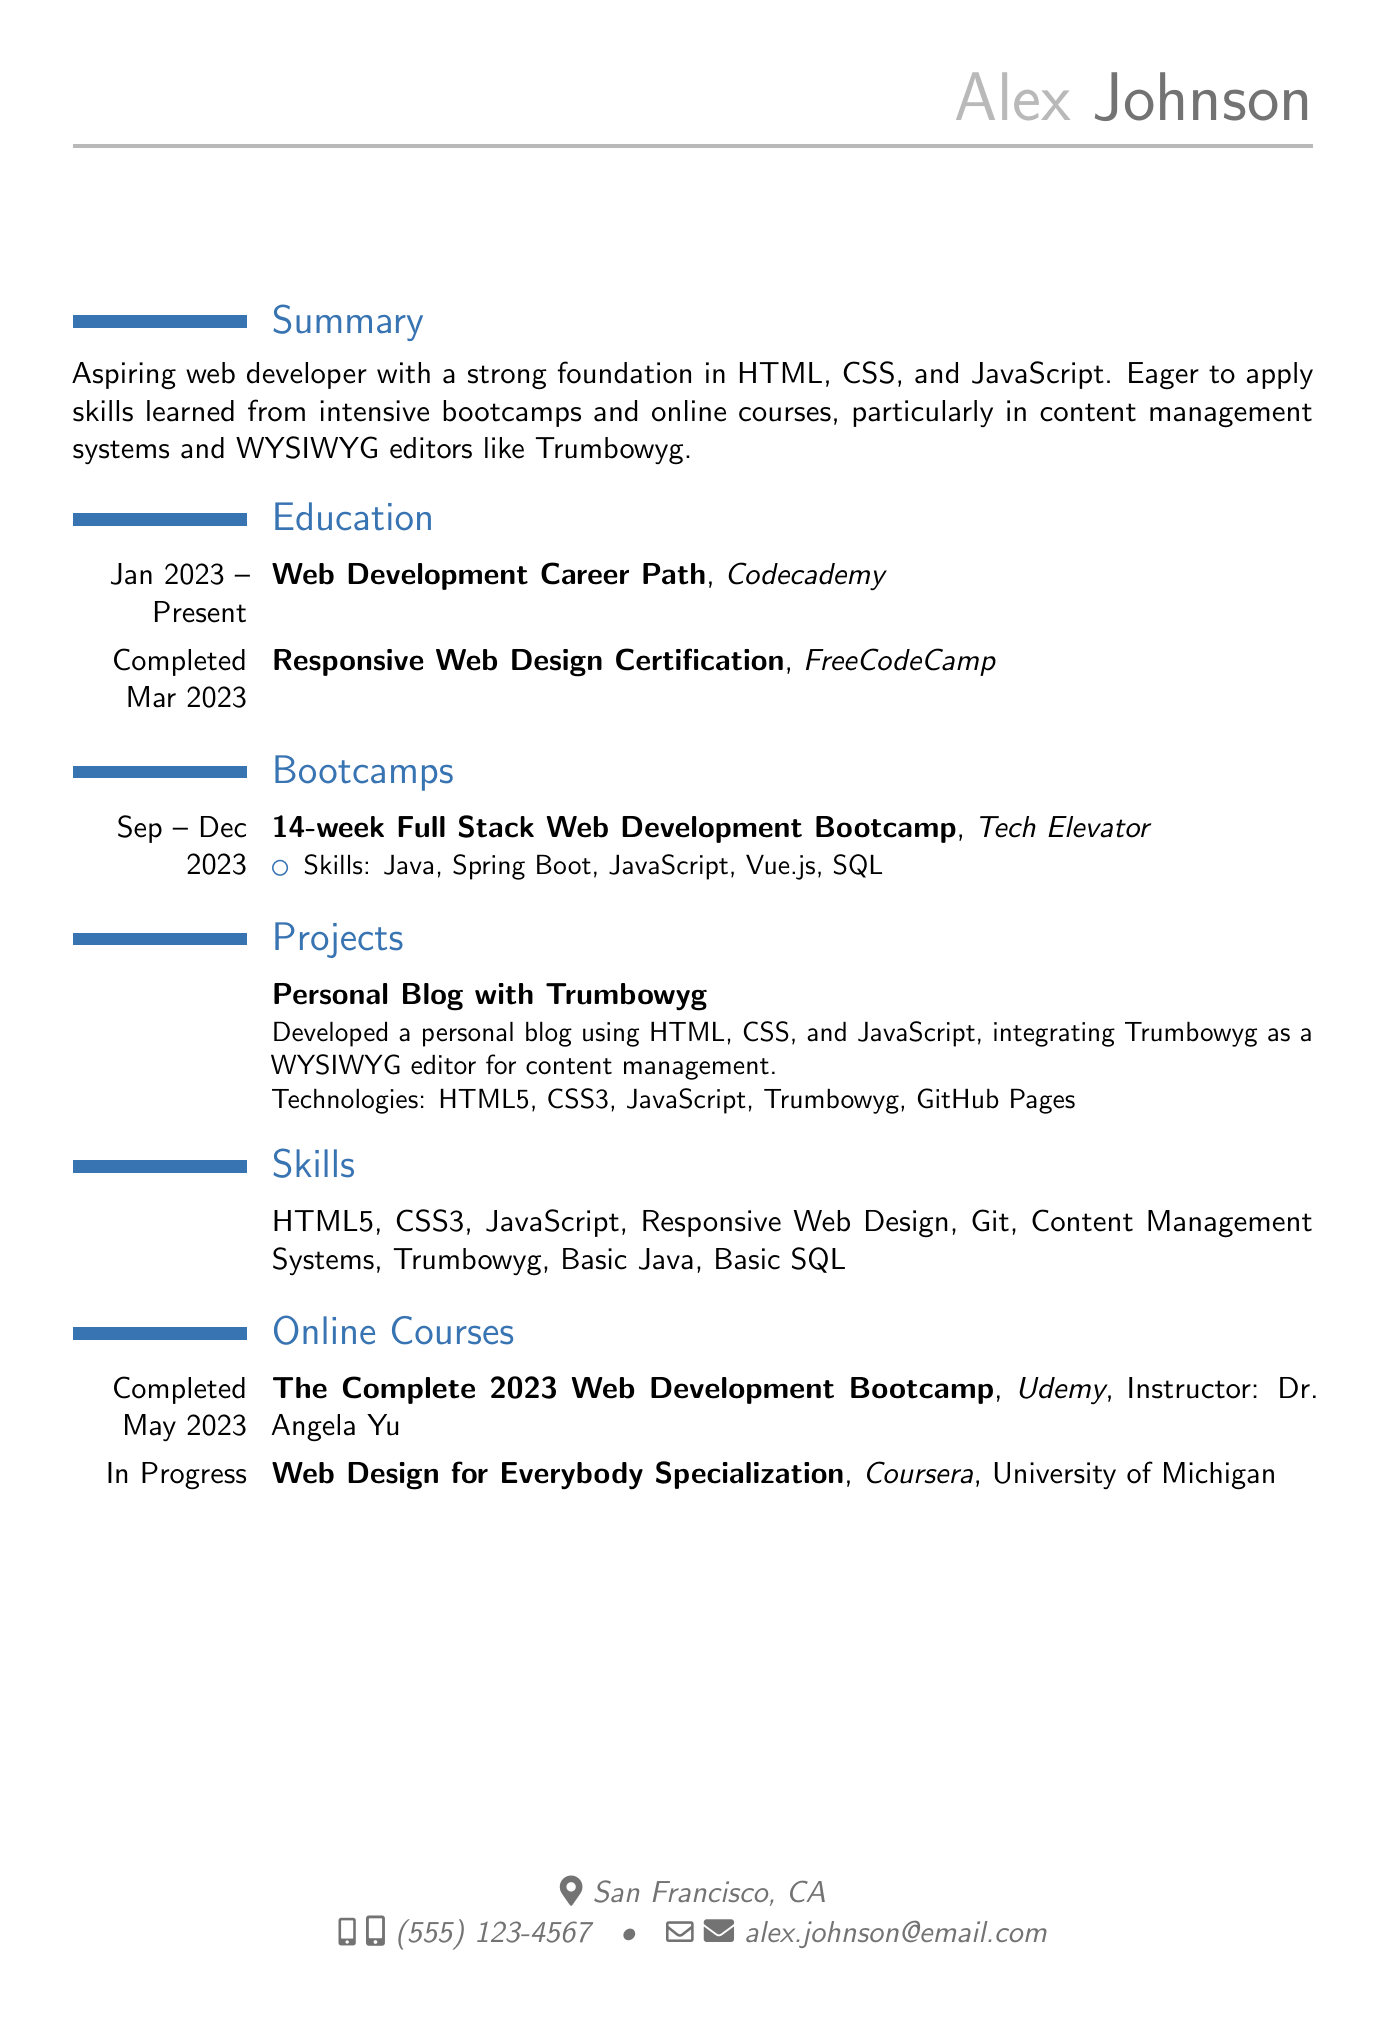what is the name of the individual in the resume? The individual in the resume is Alex Johnson.
Answer: Alex Johnson what is the contact email provided in the resume? The contact email listed in the resume is used to reach Alex Johnson.
Answer: alex.johnson@email.com which course did Alex complete in March 2023? The completed course in March 2023 is a certification in Responsive Web Design.
Answer: Responsive Web Design Certification how many weeks is the Full Stack Web Development Bootcamp? The document states that the bootcamp lasts for 14 weeks.
Answer: 14 weeks what technology was integrated into the personal blog project? The resume mentions the integration of Trumbowyg into the personal blog project.
Answer: Trumbowyg what is Alex's current online course in progress? The ongoing online course mentioned is Web Design for Everybody Specialization.
Answer: Web Design for Everybody Specialization which bootcamp did Alex attend? The bootcamp listed in the resume is Tech Elevator.
Answer: Tech Elevator what programming languages are listed as skills? The languages highlighted as skills include HTML5, CSS3, and JavaScript, among others.
Answer: HTML5, CSS3, JavaScript who is the instructor of the Udemy course? The instructor for the Udemy course is Dr. Angela Yu.
Answer: Dr. Angela Yu 